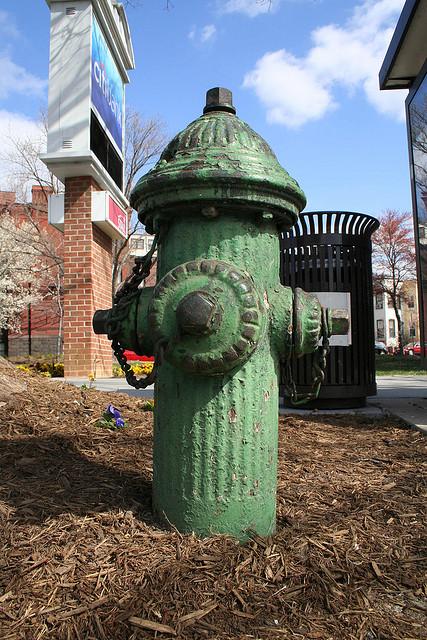How many trash bins are there?
Write a very short answer. 1. What color is the fire hydrant?
Be succinct. Green. Where is the trash can?
Answer briefly. Behind hydrant. 